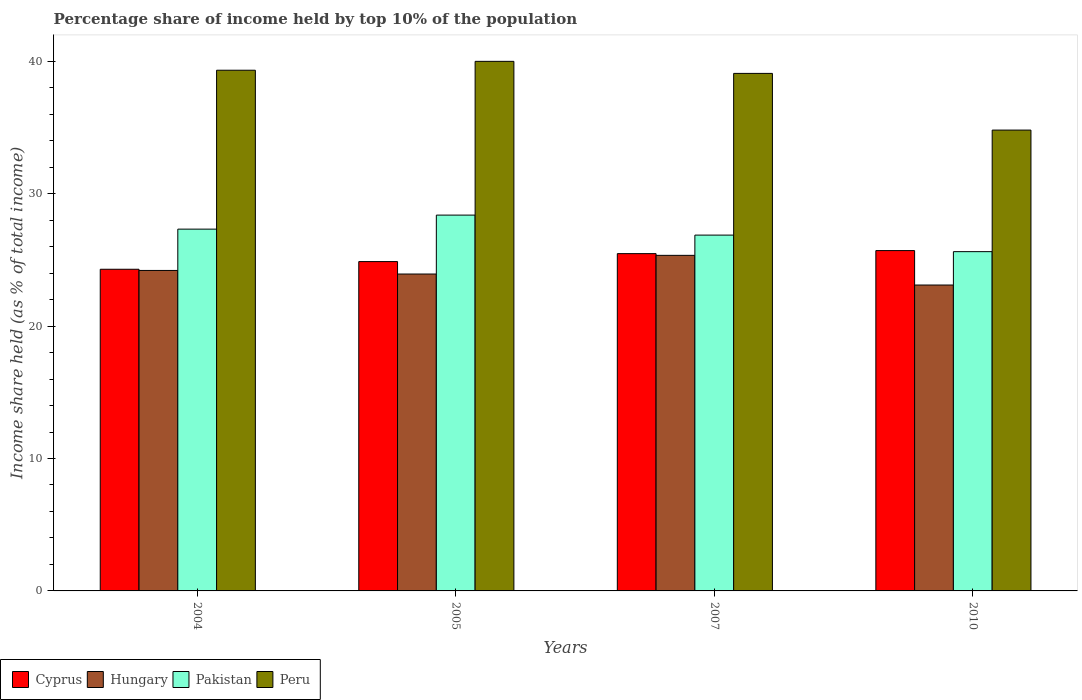How many different coloured bars are there?
Provide a succinct answer. 4. Are the number of bars per tick equal to the number of legend labels?
Make the answer very short. Yes. Are the number of bars on each tick of the X-axis equal?
Your response must be concise. Yes. How many bars are there on the 2nd tick from the left?
Provide a succinct answer. 4. How many bars are there on the 1st tick from the right?
Make the answer very short. 4. What is the label of the 4th group of bars from the left?
Keep it short and to the point. 2010. What is the percentage share of income held by top 10% of the population in Hungary in 2007?
Provide a succinct answer. 25.34. Across all years, what is the maximum percentage share of income held by top 10% of the population in Peru?
Make the answer very short. 39.99. Across all years, what is the minimum percentage share of income held by top 10% of the population in Peru?
Make the answer very short. 34.8. In which year was the percentage share of income held by top 10% of the population in Peru maximum?
Give a very brief answer. 2005. In which year was the percentage share of income held by top 10% of the population in Pakistan minimum?
Make the answer very short. 2010. What is the total percentage share of income held by top 10% of the population in Cyprus in the graph?
Your answer should be compact. 100.33. What is the difference between the percentage share of income held by top 10% of the population in Pakistan in 2007 and the percentage share of income held by top 10% of the population in Cyprus in 2004?
Offer a terse response. 2.58. What is the average percentage share of income held by top 10% of the population in Cyprus per year?
Keep it short and to the point. 25.08. In the year 2004, what is the difference between the percentage share of income held by top 10% of the population in Hungary and percentage share of income held by top 10% of the population in Pakistan?
Give a very brief answer. -3.12. In how many years, is the percentage share of income held by top 10% of the population in Peru greater than 4 %?
Give a very brief answer. 4. What is the ratio of the percentage share of income held by top 10% of the population in Hungary in 2004 to that in 2007?
Your answer should be compact. 0.96. Is the difference between the percentage share of income held by top 10% of the population in Hungary in 2005 and 2010 greater than the difference between the percentage share of income held by top 10% of the population in Pakistan in 2005 and 2010?
Your answer should be very brief. No. What is the difference between the highest and the second highest percentage share of income held by top 10% of the population in Cyprus?
Keep it short and to the point. 0.23. What is the difference between the highest and the lowest percentage share of income held by top 10% of the population in Pakistan?
Ensure brevity in your answer.  2.76. In how many years, is the percentage share of income held by top 10% of the population in Cyprus greater than the average percentage share of income held by top 10% of the population in Cyprus taken over all years?
Provide a short and direct response. 2. Is the sum of the percentage share of income held by top 10% of the population in Peru in 2004 and 2010 greater than the maximum percentage share of income held by top 10% of the population in Cyprus across all years?
Your answer should be compact. Yes. Is it the case that in every year, the sum of the percentage share of income held by top 10% of the population in Pakistan and percentage share of income held by top 10% of the population in Cyprus is greater than the sum of percentage share of income held by top 10% of the population in Hungary and percentage share of income held by top 10% of the population in Peru?
Offer a terse response. No. What does the 2nd bar from the left in 2004 represents?
Give a very brief answer. Hungary. What does the 3rd bar from the right in 2005 represents?
Your answer should be compact. Hungary. Are all the bars in the graph horizontal?
Keep it short and to the point. No. What is the difference between two consecutive major ticks on the Y-axis?
Your response must be concise. 10. Where does the legend appear in the graph?
Make the answer very short. Bottom left. What is the title of the graph?
Your answer should be compact. Percentage share of income held by top 10% of the population. Does "Eritrea" appear as one of the legend labels in the graph?
Keep it short and to the point. No. What is the label or title of the X-axis?
Offer a very short reply. Years. What is the label or title of the Y-axis?
Provide a short and direct response. Income share held (as % of total income). What is the Income share held (as % of total income) of Cyprus in 2004?
Provide a short and direct response. 24.29. What is the Income share held (as % of total income) of Hungary in 2004?
Provide a succinct answer. 24.2. What is the Income share held (as % of total income) of Pakistan in 2004?
Your answer should be compact. 27.32. What is the Income share held (as % of total income) of Peru in 2004?
Provide a short and direct response. 39.32. What is the Income share held (as % of total income) in Cyprus in 2005?
Offer a terse response. 24.87. What is the Income share held (as % of total income) in Hungary in 2005?
Offer a very short reply. 23.93. What is the Income share held (as % of total income) of Pakistan in 2005?
Give a very brief answer. 28.38. What is the Income share held (as % of total income) in Peru in 2005?
Your response must be concise. 39.99. What is the Income share held (as % of total income) of Cyprus in 2007?
Provide a succinct answer. 25.47. What is the Income share held (as % of total income) in Hungary in 2007?
Your answer should be compact. 25.34. What is the Income share held (as % of total income) of Pakistan in 2007?
Your answer should be very brief. 26.87. What is the Income share held (as % of total income) in Peru in 2007?
Give a very brief answer. 39.08. What is the Income share held (as % of total income) of Cyprus in 2010?
Make the answer very short. 25.7. What is the Income share held (as % of total income) in Hungary in 2010?
Provide a short and direct response. 23.1. What is the Income share held (as % of total income) of Pakistan in 2010?
Your response must be concise. 25.62. What is the Income share held (as % of total income) in Peru in 2010?
Your answer should be compact. 34.8. Across all years, what is the maximum Income share held (as % of total income) of Cyprus?
Your answer should be compact. 25.7. Across all years, what is the maximum Income share held (as % of total income) of Hungary?
Keep it short and to the point. 25.34. Across all years, what is the maximum Income share held (as % of total income) in Pakistan?
Provide a succinct answer. 28.38. Across all years, what is the maximum Income share held (as % of total income) of Peru?
Provide a succinct answer. 39.99. Across all years, what is the minimum Income share held (as % of total income) of Cyprus?
Offer a very short reply. 24.29. Across all years, what is the minimum Income share held (as % of total income) in Hungary?
Give a very brief answer. 23.1. Across all years, what is the minimum Income share held (as % of total income) in Pakistan?
Provide a succinct answer. 25.62. Across all years, what is the minimum Income share held (as % of total income) in Peru?
Offer a very short reply. 34.8. What is the total Income share held (as % of total income) in Cyprus in the graph?
Provide a succinct answer. 100.33. What is the total Income share held (as % of total income) in Hungary in the graph?
Ensure brevity in your answer.  96.57. What is the total Income share held (as % of total income) in Pakistan in the graph?
Provide a succinct answer. 108.19. What is the total Income share held (as % of total income) of Peru in the graph?
Give a very brief answer. 153.19. What is the difference between the Income share held (as % of total income) in Cyprus in 2004 and that in 2005?
Give a very brief answer. -0.58. What is the difference between the Income share held (as % of total income) of Hungary in 2004 and that in 2005?
Offer a terse response. 0.27. What is the difference between the Income share held (as % of total income) in Pakistan in 2004 and that in 2005?
Offer a terse response. -1.06. What is the difference between the Income share held (as % of total income) in Peru in 2004 and that in 2005?
Offer a very short reply. -0.67. What is the difference between the Income share held (as % of total income) of Cyprus in 2004 and that in 2007?
Give a very brief answer. -1.18. What is the difference between the Income share held (as % of total income) in Hungary in 2004 and that in 2007?
Offer a very short reply. -1.14. What is the difference between the Income share held (as % of total income) of Pakistan in 2004 and that in 2007?
Make the answer very short. 0.45. What is the difference between the Income share held (as % of total income) of Peru in 2004 and that in 2007?
Keep it short and to the point. 0.24. What is the difference between the Income share held (as % of total income) of Cyprus in 2004 and that in 2010?
Offer a terse response. -1.41. What is the difference between the Income share held (as % of total income) in Peru in 2004 and that in 2010?
Your answer should be very brief. 4.52. What is the difference between the Income share held (as % of total income) in Hungary in 2005 and that in 2007?
Your answer should be compact. -1.41. What is the difference between the Income share held (as % of total income) in Pakistan in 2005 and that in 2007?
Ensure brevity in your answer.  1.51. What is the difference between the Income share held (as % of total income) of Peru in 2005 and that in 2007?
Your answer should be compact. 0.91. What is the difference between the Income share held (as % of total income) in Cyprus in 2005 and that in 2010?
Your answer should be compact. -0.83. What is the difference between the Income share held (as % of total income) in Hungary in 2005 and that in 2010?
Give a very brief answer. 0.83. What is the difference between the Income share held (as % of total income) of Pakistan in 2005 and that in 2010?
Give a very brief answer. 2.76. What is the difference between the Income share held (as % of total income) in Peru in 2005 and that in 2010?
Your answer should be very brief. 5.19. What is the difference between the Income share held (as % of total income) of Cyprus in 2007 and that in 2010?
Give a very brief answer. -0.23. What is the difference between the Income share held (as % of total income) in Hungary in 2007 and that in 2010?
Offer a very short reply. 2.24. What is the difference between the Income share held (as % of total income) of Peru in 2007 and that in 2010?
Offer a terse response. 4.28. What is the difference between the Income share held (as % of total income) in Cyprus in 2004 and the Income share held (as % of total income) in Hungary in 2005?
Your answer should be compact. 0.36. What is the difference between the Income share held (as % of total income) of Cyprus in 2004 and the Income share held (as % of total income) of Pakistan in 2005?
Ensure brevity in your answer.  -4.09. What is the difference between the Income share held (as % of total income) of Cyprus in 2004 and the Income share held (as % of total income) of Peru in 2005?
Provide a short and direct response. -15.7. What is the difference between the Income share held (as % of total income) of Hungary in 2004 and the Income share held (as % of total income) of Pakistan in 2005?
Your answer should be compact. -4.18. What is the difference between the Income share held (as % of total income) of Hungary in 2004 and the Income share held (as % of total income) of Peru in 2005?
Provide a short and direct response. -15.79. What is the difference between the Income share held (as % of total income) in Pakistan in 2004 and the Income share held (as % of total income) in Peru in 2005?
Offer a very short reply. -12.67. What is the difference between the Income share held (as % of total income) of Cyprus in 2004 and the Income share held (as % of total income) of Hungary in 2007?
Make the answer very short. -1.05. What is the difference between the Income share held (as % of total income) in Cyprus in 2004 and the Income share held (as % of total income) in Pakistan in 2007?
Your response must be concise. -2.58. What is the difference between the Income share held (as % of total income) of Cyprus in 2004 and the Income share held (as % of total income) of Peru in 2007?
Give a very brief answer. -14.79. What is the difference between the Income share held (as % of total income) of Hungary in 2004 and the Income share held (as % of total income) of Pakistan in 2007?
Your response must be concise. -2.67. What is the difference between the Income share held (as % of total income) in Hungary in 2004 and the Income share held (as % of total income) in Peru in 2007?
Offer a very short reply. -14.88. What is the difference between the Income share held (as % of total income) of Pakistan in 2004 and the Income share held (as % of total income) of Peru in 2007?
Your response must be concise. -11.76. What is the difference between the Income share held (as % of total income) in Cyprus in 2004 and the Income share held (as % of total income) in Hungary in 2010?
Offer a terse response. 1.19. What is the difference between the Income share held (as % of total income) in Cyprus in 2004 and the Income share held (as % of total income) in Pakistan in 2010?
Your answer should be compact. -1.33. What is the difference between the Income share held (as % of total income) in Cyprus in 2004 and the Income share held (as % of total income) in Peru in 2010?
Provide a succinct answer. -10.51. What is the difference between the Income share held (as % of total income) of Hungary in 2004 and the Income share held (as % of total income) of Pakistan in 2010?
Your answer should be very brief. -1.42. What is the difference between the Income share held (as % of total income) in Hungary in 2004 and the Income share held (as % of total income) in Peru in 2010?
Your response must be concise. -10.6. What is the difference between the Income share held (as % of total income) in Pakistan in 2004 and the Income share held (as % of total income) in Peru in 2010?
Give a very brief answer. -7.48. What is the difference between the Income share held (as % of total income) of Cyprus in 2005 and the Income share held (as % of total income) of Hungary in 2007?
Make the answer very short. -0.47. What is the difference between the Income share held (as % of total income) in Cyprus in 2005 and the Income share held (as % of total income) in Peru in 2007?
Provide a short and direct response. -14.21. What is the difference between the Income share held (as % of total income) of Hungary in 2005 and the Income share held (as % of total income) of Pakistan in 2007?
Your answer should be very brief. -2.94. What is the difference between the Income share held (as % of total income) of Hungary in 2005 and the Income share held (as % of total income) of Peru in 2007?
Offer a terse response. -15.15. What is the difference between the Income share held (as % of total income) of Pakistan in 2005 and the Income share held (as % of total income) of Peru in 2007?
Your response must be concise. -10.7. What is the difference between the Income share held (as % of total income) of Cyprus in 2005 and the Income share held (as % of total income) of Hungary in 2010?
Your answer should be compact. 1.77. What is the difference between the Income share held (as % of total income) in Cyprus in 2005 and the Income share held (as % of total income) in Pakistan in 2010?
Give a very brief answer. -0.75. What is the difference between the Income share held (as % of total income) in Cyprus in 2005 and the Income share held (as % of total income) in Peru in 2010?
Offer a very short reply. -9.93. What is the difference between the Income share held (as % of total income) of Hungary in 2005 and the Income share held (as % of total income) of Pakistan in 2010?
Give a very brief answer. -1.69. What is the difference between the Income share held (as % of total income) in Hungary in 2005 and the Income share held (as % of total income) in Peru in 2010?
Offer a very short reply. -10.87. What is the difference between the Income share held (as % of total income) in Pakistan in 2005 and the Income share held (as % of total income) in Peru in 2010?
Your response must be concise. -6.42. What is the difference between the Income share held (as % of total income) of Cyprus in 2007 and the Income share held (as % of total income) of Hungary in 2010?
Keep it short and to the point. 2.37. What is the difference between the Income share held (as % of total income) of Cyprus in 2007 and the Income share held (as % of total income) of Pakistan in 2010?
Offer a terse response. -0.15. What is the difference between the Income share held (as % of total income) of Cyprus in 2007 and the Income share held (as % of total income) of Peru in 2010?
Offer a terse response. -9.33. What is the difference between the Income share held (as % of total income) in Hungary in 2007 and the Income share held (as % of total income) in Pakistan in 2010?
Provide a succinct answer. -0.28. What is the difference between the Income share held (as % of total income) of Hungary in 2007 and the Income share held (as % of total income) of Peru in 2010?
Your answer should be compact. -9.46. What is the difference between the Income share held (as % of total income) of Pakistan in 2007 and the Income share held (as % of total income) of Peru in 2010?
Offer a terse response. -7.93. What is the average Income share held (as % of total income) of Cyprus per year?
Offer a terse response. 25.08. What is the average Income share held (as % of total income) in Hungary per year?
Your response must be concise. 24.14. What is the average Income share held (as % of total income) of Pakistan per year?
Your answer should be very brief. 27.05. What is the average Income share held (as % of total income) of Peru per year?
Your answer should be very brief. 38.3. In the year 2004, what is the difference between the Income share held (as % of total income) of Cyprus and Income share held (as % of total income) of Hungary?
Offer a very short reply. 0.09. In the year 2004, what is the difference between the Income share held (as % of total income) in Cyprus and Income share held (as % of total income) in Pakistan?
Make the answer very short. -3.03. In the year 2004, what is the difference between the Income share held (as % of total income) of Cyprus and Income share held (as % of total income) of Peru?
Your response must be concise. -15.03. In the year 2004, what is the difference between the Income share held (as % of total income) in Hungary and Income share held (as % of total income) in Pakistan?
Give a very brief answer. -3.12. In the year 2004, what is the difference between the Income share held (as % of total income) of Hungary and Income share held (as % of total income) of Peru?
Your answer should be compact. -15.12. In the year 2005, what is the difference between the Income share held (as % of total income) in Cyprus and Income share held (as % of total income) in Hungary?
Make the answer very short. 0.94. In the year 2005, what is the difference between the Income share held (as % of total income) in Cyprus and Income share held (as % of total income) in Pakistan?
Offer a very short reply. -3.51. In the year 2005, what is the difference between the Income share held (as % of total income) of Cyprus and Income share held (as % of total income) of Peru?
Provide a short and direct response. -15.12. In the year 2005, what is the difference between the Income share held (as % of total income) in Hungary and Income share held (as % of total income) in Pakistan?
Give a very brief answer. -4.45. In the year 2005, what is the difference between the Income share held (as % of total income) in Hungary and Income share held (as % of total income) in Peru?
Your answer should be compact. -16.06. In the year 2005, what is the difference between the Income share held (as % of total income) of Pakistan and Income share held (as % of total income) of Peru?
Your response must be concise. -11.61. In the year 2007, what is the difference between the Income share held (as % of total income) of Cyprus and Income share held (as % of total income) of Hungary?
Keep it short and to the point. 0.13. In the year 2007, what is the difference between the Income share held (as % of total income) of Cyprus and Income share held (as % of total income) of Pakistan?
Your response must be concise. -1.4. In the year 2007, what is the difference between the Income share held (as % of total income) of Cyprus and Income share held (as % of total income) of Peru?
Give a very brief answer. -13.61. In the year 2007, what is the difference between the Income share held (as % of total income) of Hungary and Income share held (as % of total income) of Pakistan?
Provide a succinct answer. -1.53. In the year 2007, what is the difference between the Income share held (as % of total income) of Hungary and Income share held (as % of total income) of Peru?
Your answer should be very brief. -13.74. In the year 2007, what is the difference between the Income share held (as % of total income) of Pakistan and Income share held (as % of total income) of Peru?
Keep it short and to the point. -12.21. In the year 2010, what is the difference between the Income share held (as % of total income) in Cyprus and Income share held (as % of total income) in Pakistan?
Offer a very short reply. 0.08. In the year 2010, what is the difference between the Income share held (as % of total income) of Cyprus and Income share held (as % of total income) of Peru?
Give a very brief answer. -9.1. In the year 2010, what is the difference between the Income share held (as % of total income) in Hungary and Income share held (as % of total income) in Pakistan?
Provide a succinct answer. -2.52. In the year 2010, what is the difference between the Income share held (as % of total income) in Hungary and Income share held (as % of total income) in Peru?
Give a very brief answer. -11.7. In the year 2010, what is the difference between the Income share held (as % of total income) in Pakistan and Income share held (as % of total income) in Peru?
Give a very brief answer. -9.18. What is the ratio of the Income share held (as % of total income) in Cyprus in 2004 to that in 2005?
Ensure brevity in your answer.  0.98. What is the ratio of the Income share held (as % of total income) in Hungary in 2004 to that in 2005?
Make the answer very short. 1.01. What is the ratio of the Income share held (as % of total income) in Pakistan in 2004 to that in 2005?
Your answer should be compact. 0.96. What is the ratio of the Income share held (as % of total income) of Peru in 2004 to that in 2005?
Offer a very short reply. 0.98. What is the ratio of the Income share held (as % of total income) in Cyprus in 2004 to that in 2007?
Offer a very short reply. 0.95. What is the ratio of the Income share held (as % of total income) in Hungary in 2004 to that in 2007?
Give a very brief answer. 0.95. What is the ratio of the Income share held (as % of total income) of Pakistan in 2004 to that in 2007?
Your response must be concise. 1.02. What is the ratio of the Income share held (as % of total income) in Cyprus in 2004 to that in 2010?
Ensure brevity in your answer.  0.95. What is the ratio of the Income share held (as % of total income) in Hungary in 2004 to that in 2010?
Your answer should be very brief. 1.05. What is the ratio of the Income share held (as % of total income) of Pakistan in 2004 to that in 2010?
Provide a succinct answer. 1.07. What is the ratio of the Income share held (as % of total income) in Peru in 2004 to that in 2010?
Ensure brevity in your answer.  1.13. What is the ratio of the Income share held (as % of total income) of Cyprus in 2005 to that in 2007?
Your response must be concise. 0.98. What is the ratio of the Income share held (as % of total income) of Hungary in 2005 to that in 2007?
Give a very brief answer. 0.94. What is the ratio of the Income share held (as % of total income) in Pakistan in 2005 to that in 2007?
Your answer should be compact. 1.06. What is the ratio of the Income share held (as % of total income) in Peru in 2005 to that in 2007?
Provide a short and direct response. 1.02. What is the ratio of the Income share held (as % of total income) in Cyprus in 2005 to that in 2010?
Make the answer very short. 0.97. What is the ratio of the Income share held (as % of total income) of Hungary in 2005 to that in 2010?
Ensure brevity in your answer.  1.04. What is the ratio of the Income share held (as % of total income) in Pakistan in 2005 to that in 2010?
Your answer should be very brief. 1.11. What is the ratio of the Income share held (as % of total income) in Peru in 2005 to that in 2010?
Provide a short and direct response. 1.15. What is the ratio of the Income share held (as % of total income) of Hungary in 2007 to that in 2010?
Your answer should be very brief. 1.1. What is the ratio of the Income share held (as % of total income) in Pakistan in 2007 to that in 2010?
Ensure brevity in your answer.  1.05. What is the ratio of the Income share held (as % of total income) in Peru in 2007 to that in 2010?
Keep it short and to the point. 1.12. What is the difference between the highest and the second highest Income share held (as % of total income) of Cyprus?
Keep it short and to the point. 0.23. What is the difference between the highest and the second highest Income share held (as % of total income) in Hungary?
Provide a succinct answer. 1.14. What is the difference between the highest and the second highest Income share held (as % of total income) of Pakistan?
Give a very brief answer. 1.06. What is the difference between the highest and the second highest Income share held (as % of total income) of Peru?
Offer a terse response. 0.67. What is the difference between the highest and the lowest Income share held (as % of total income) in Cyprus?
Provide a succinct answer. 1.41. What is the difference between the highest and the lowest Income share held (as % of total income) in Hungary?
Your response must be concise. 2.24. What is the difference between the highest and the lowest Income share held (as % of total income) of Pakistan?
Provide a succinct answer. 2.76. What is the difference between the highest and the lowest Income share held (as % of total income) in Peru?
Your answer should be compact. 5.19. 